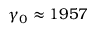Convert formula to latex. <formula><loc_0><loc_0><loc_500><loc_500>\gamma _ { 0 } \approx 1 9 5 7</formula> 